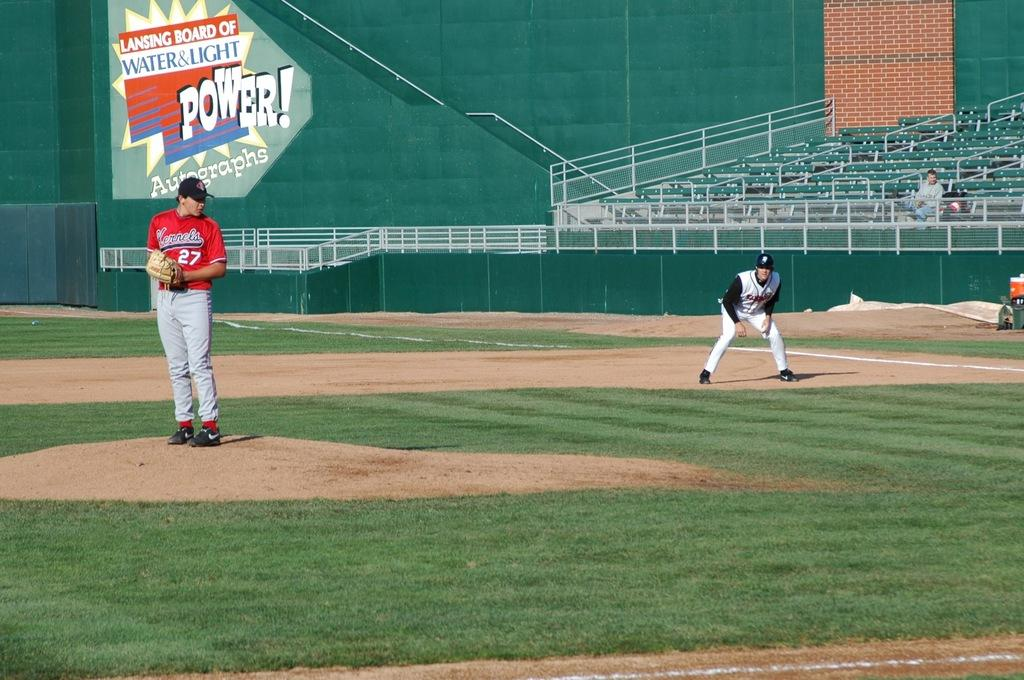<image>
Render a clear and concise summary of the photo. Player number 27 for the Kernels stands on the mound. 